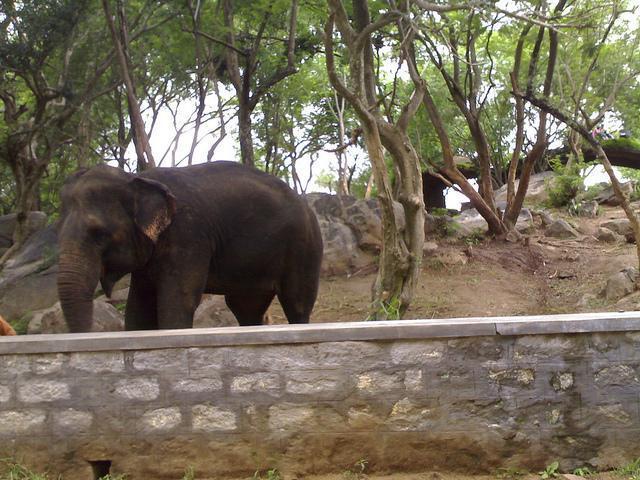How many toothbrushes are in the cup?
Give a very brief answer. 0. 